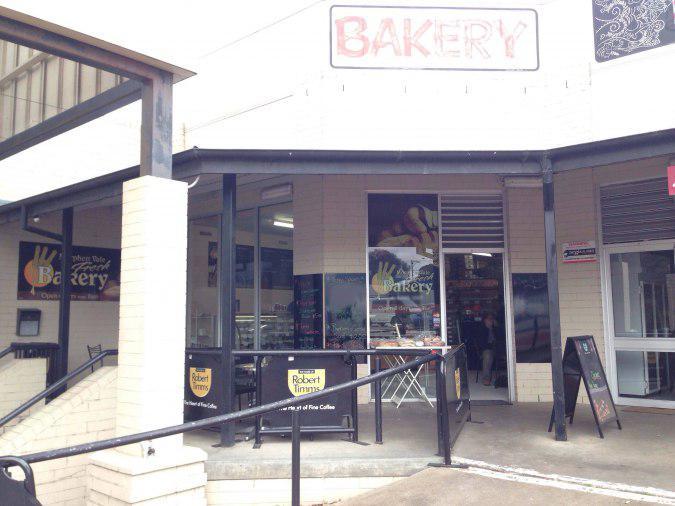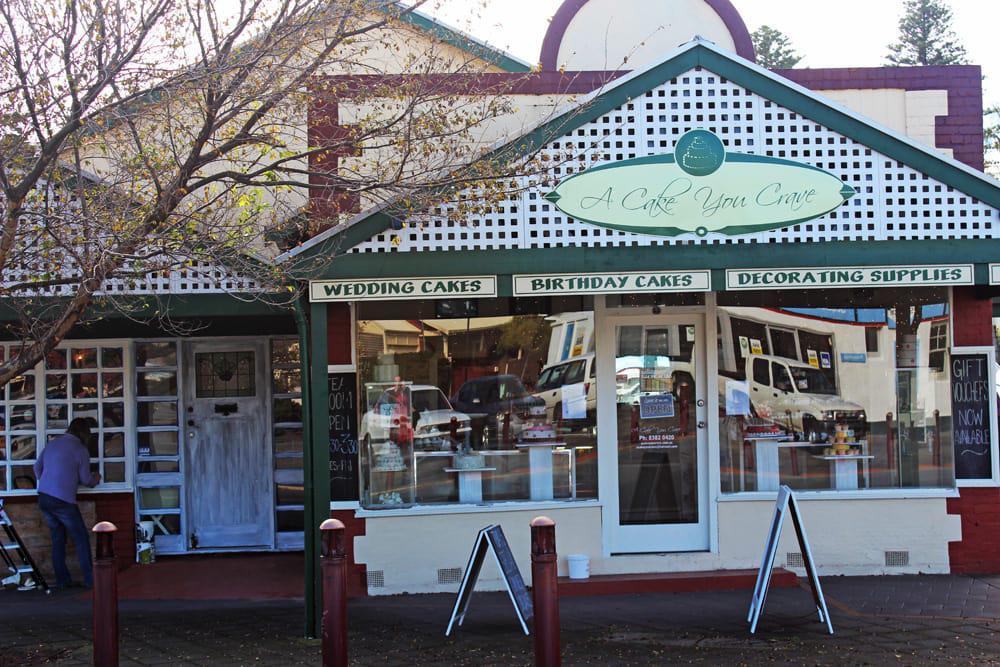The first image is the image on the left, the second image is the image on the right. For the images displayed, is the sentence "A single person is outside of the shop in one of the images." factually correct? Answer yes or no. Yes. The first image is the image on the left, the second image is the image on the right. Analyze the images presented: Is the assertion "There are awnings over the doors of both bakeries." valid? Answer yes or no. No. 